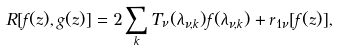<formula> <loc_0><loc_0><loc_500><loc_500>R [ f ( z ) , g ( z ) ] = 2 \sum _ { k } T _ { \nu } ( \lambda _ { \nu , k } ) f ( \lambda _ { \nu , k } ) + r _ { 1 \nu } [ f ( z ) ] ,</formula> 